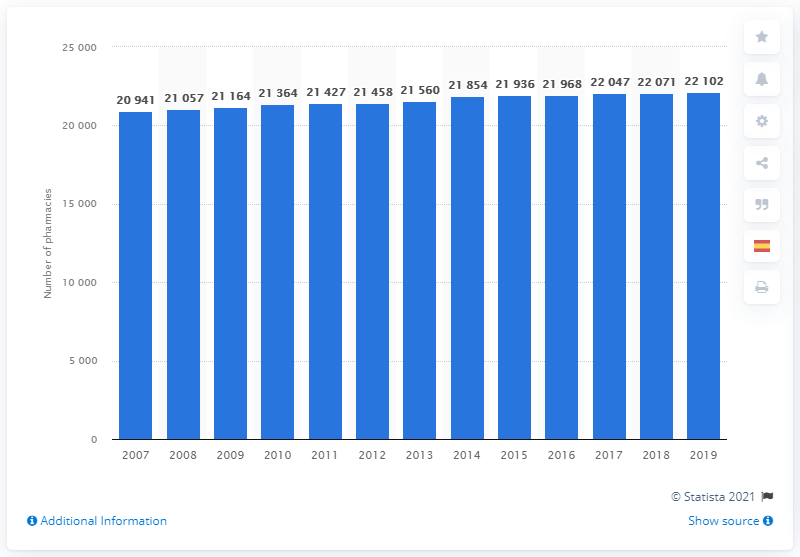Draw attention to some important aspects in this diagram. There were 22,102 pharmacies in Spain in 2019. 